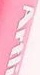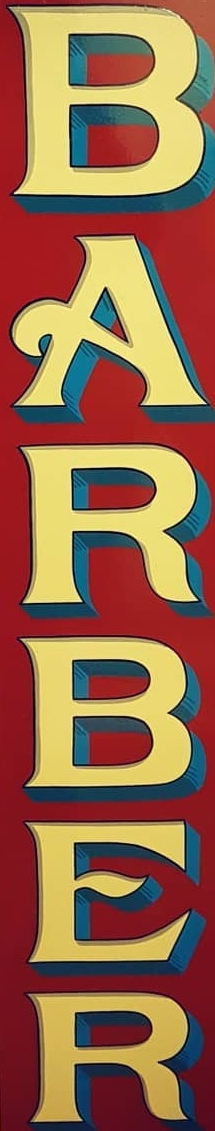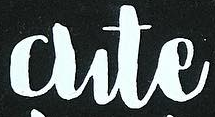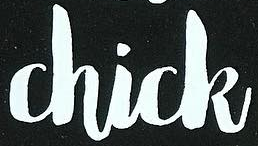What words can you see in these images in sequence, separated by a semicolon? Artli; BARBER; Cute; Chick 